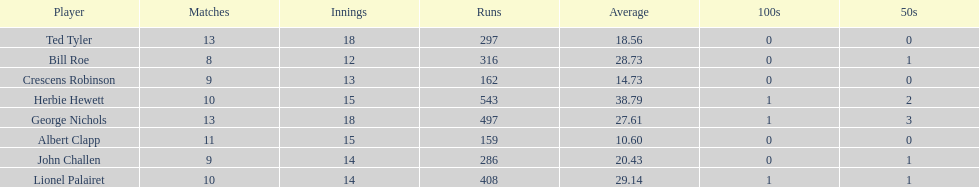What were the number of innings albert clapp had? 15. 